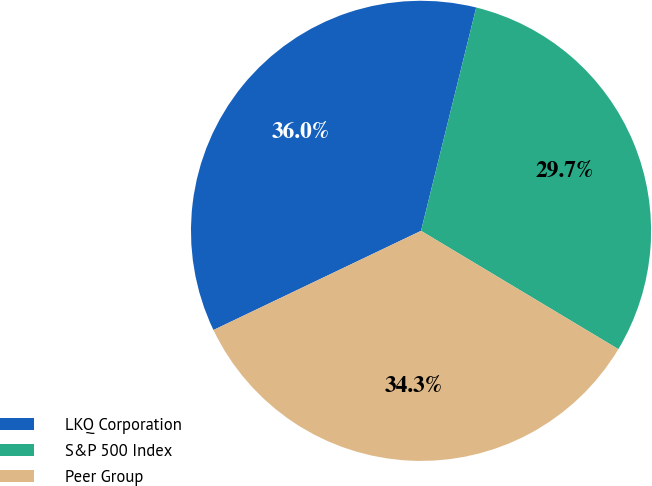<chart> <loc_0><loc_0><loc_500><loc_500><pie_chart><fcel>LKQ Corporation<fcel>S&P 500 Index<fcel>Peer Group<nl><fcel>35.95%<fcel>29.74%<fcel>34.31%<nl></chart> 